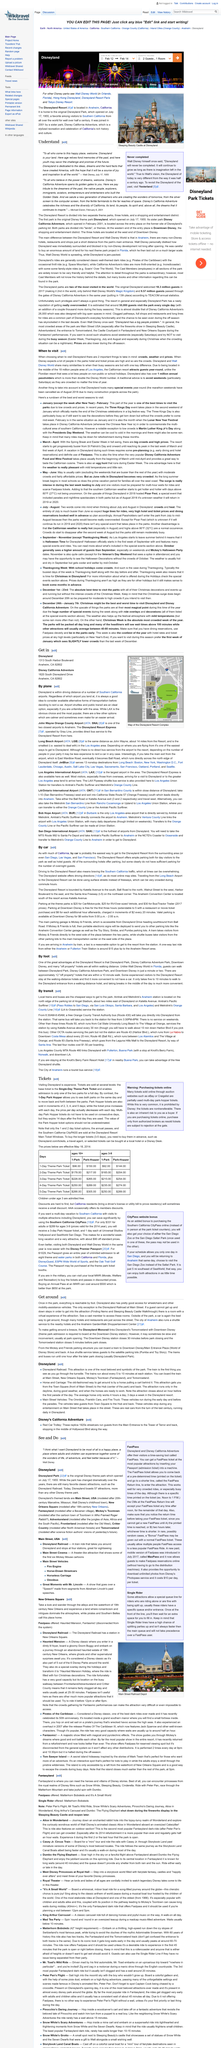Specify some key components in this picture. The Disneyland Railroad is the most beloved and symbolic attraction of the park, embodying the magic and wonder that is uniquely Disney. The original Disneyland Park was officially opened on July 17, 1955, and has since become a beloved destination for visitors of all ages. It is possible to explore and access all attractions and amenities at Disneyland by foot, as foot traffic is the primary mode of transportation within the park. Weekends are traditionally the most crowded days to visit Disneyland, regardless of the time of year. The old-fashioned way to get around is the horse and carriage. 